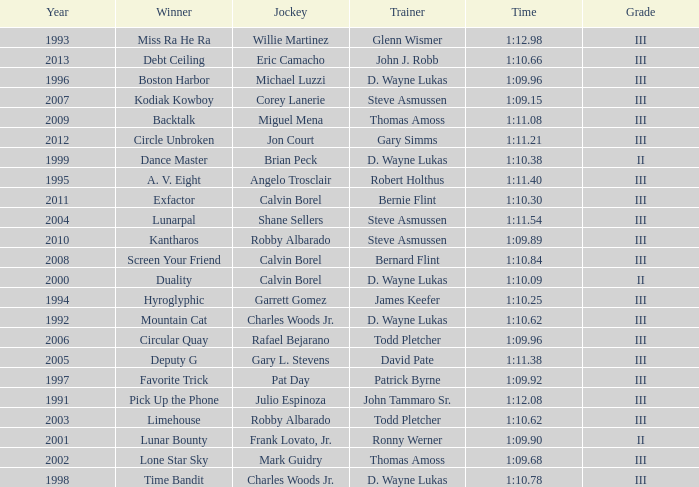Which trainer had a time of 1:10.09 with a year less than 2009? D. Wayne Lukas. Write the full table. {'header': ['Year', 'Winner', 'Jockey', 'Trainer', 'Time', 'Grade'], 'rows': [['1993', 'Miss Ra He Ra', 'Willie Martinez', 'Glenn Wismer', '1:12.98', 'III'], ['2013', 'Debt Ceiling', 'Eric Camacho', 'John J. Robb', '1:10.66', 'III'], ['1996', 'Boston Harbor', 'Michael Luzzi', 'D. Wayne Lukas', '1:09.96', 'III'], ['2007', 'Kodiak Kowboy', 'Corey Lanerie', 'Steve Asmussen', '1:09.15', 'III'], ['2009', 'Backtalk', 'Miguel Mena', 'Thomas Amoss', '1:11.08', 'III'], ['2012', 'Circle Unbroken', 'Jon Court', 'Gary Simms', '1:11.21', 'III'], ['1999', 'Dance Master', 'Brian Peck', 'D. Wayne Lukas', '1:10.38', 'II'], ['1995', 'A. V. Eight', 'Angelo Trosclair', 'Robert Holthus', '1:11.40', 'III'], ['2011', 'Exfactor', 'Calvin Borel', 'Bernie Flint', '1:10.30', 'III'], ['2004', 'Lunarpal', 'Shane Sellers', 'Steve Asmussen', '1:11.54', 'III'], ['2010', 'Kantharos', 'Robby Albarado', 'Steve Asmussen', '1:09.89', 'III'], ['2008', 'Screen Your Friend', 'Calvin Borel', 'Bernard Flint', '1:10.84', 'III'], ['2000', 'Duality', 'Calvin Borel', 'D. Wayne Lukas', '1:10.09', 'II'], ['1994', 'Hyroglyphic', 'Garrett Gomez', 'James Keefer', '1:10.25', 'III'], ['1992', 'Mountain Cat', 'Charles Woods Jr.', 'D. Wayne Lukas', '1:10.62', 'III'], ['2006', 'Circular Quay', 'Rafael Bejarano', 'Todd Pletcher', '1:09.96', 'III'], ['2005', 'Deputy G', 'Gary L. Stevens', 'David Pate', '1:11.38', 'III'], ['1997', 'Favorite Trick', 'Pat Day', 'Patrick Byrne', '1:09.92', 'III'], ['1991', 'Pick Up the Phone', 'Julio Espinoza', 'John Tammaro Sr.', '1:12.08', 'III'], ['2003', 'Limehouse', 'Robby Albarado', 'Todd Pletcher', '1:10.62', 'III'], ['2001', 'Lunar Bounty', 'Frank Lovato, Jr.', 'Ronny Werner', '1:09.90', 'II'], ['2002', 'Lone Star Sky', 'Mark Guidry', 'Thomas Amoss', '1:09.68', 'III'], ['1998', 'Time Bandit', 'Charles Woods Jr.', 'D. Wayne Lukas', '1:10.78', 'III']]} 